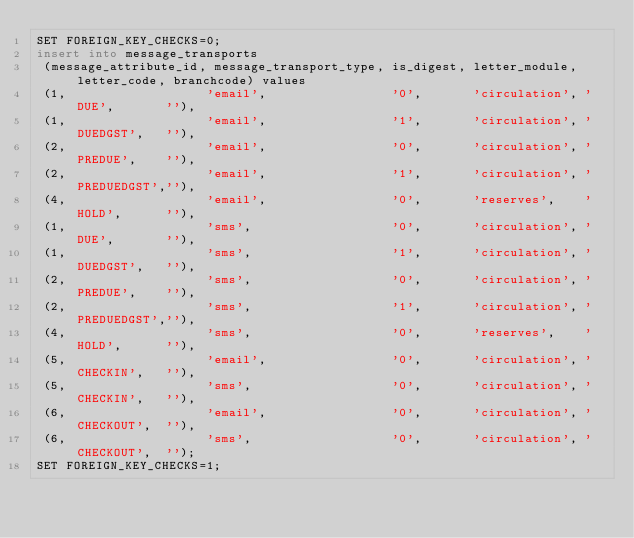Convert code to text. <code><loc_0><loc_0><loc_500><loc_500><_SQL_>SET FOREIGN_KEY_CHECKS=0;
insert into message_transports
 (message_attribute_id, message_transport_type, is_digest, letter_module, letter_code, branchcode) values
 (1,                   'email',                 '0',       'circulation', 'DUE',       ''),
 (1,                   'email',                 '1',       'circulation', 'DUEDGST',   ''),
 (2,                   'email',                 '0',       'circulation', 'PREDUE',    ''),
 (2,                   'email',                 '1',       'circulation', 'PREDUEDGST',''),
 (4,                   'email',                 '0',       'reserves',    'HOLD',      ''),
 (1,                   'sms',                   '0',       'circulation', 'DUE',       ''),
 (1,                   'sms',                   '1',       'circulation', 'DUEDGST',   ''),
 (2,                   'sms',                   '0',       'circulation', 'PREDUE',    ''),
 (2,                   'sms',                   '1',       'circulation', 'PREDUEDGST',''),
 (4,                   'sms',                   '0',       'reserves',    'HOLD',      ''),
 (5,                   'email',                 '0',       'circulation', 'CHECKIN',   ''),
 (5,                   'sms',                   '0',       'circulation', 'CHECKIN',   ''),
 (6,                   'email',                 '0',       'circulation', 'CHECKOUT',  ''),
 (6,                   'sms',                   '0',       'circulation', 'CHECKOUT',  '');
SET FOREIGN_KEY_CHECKS=1;

</code> 